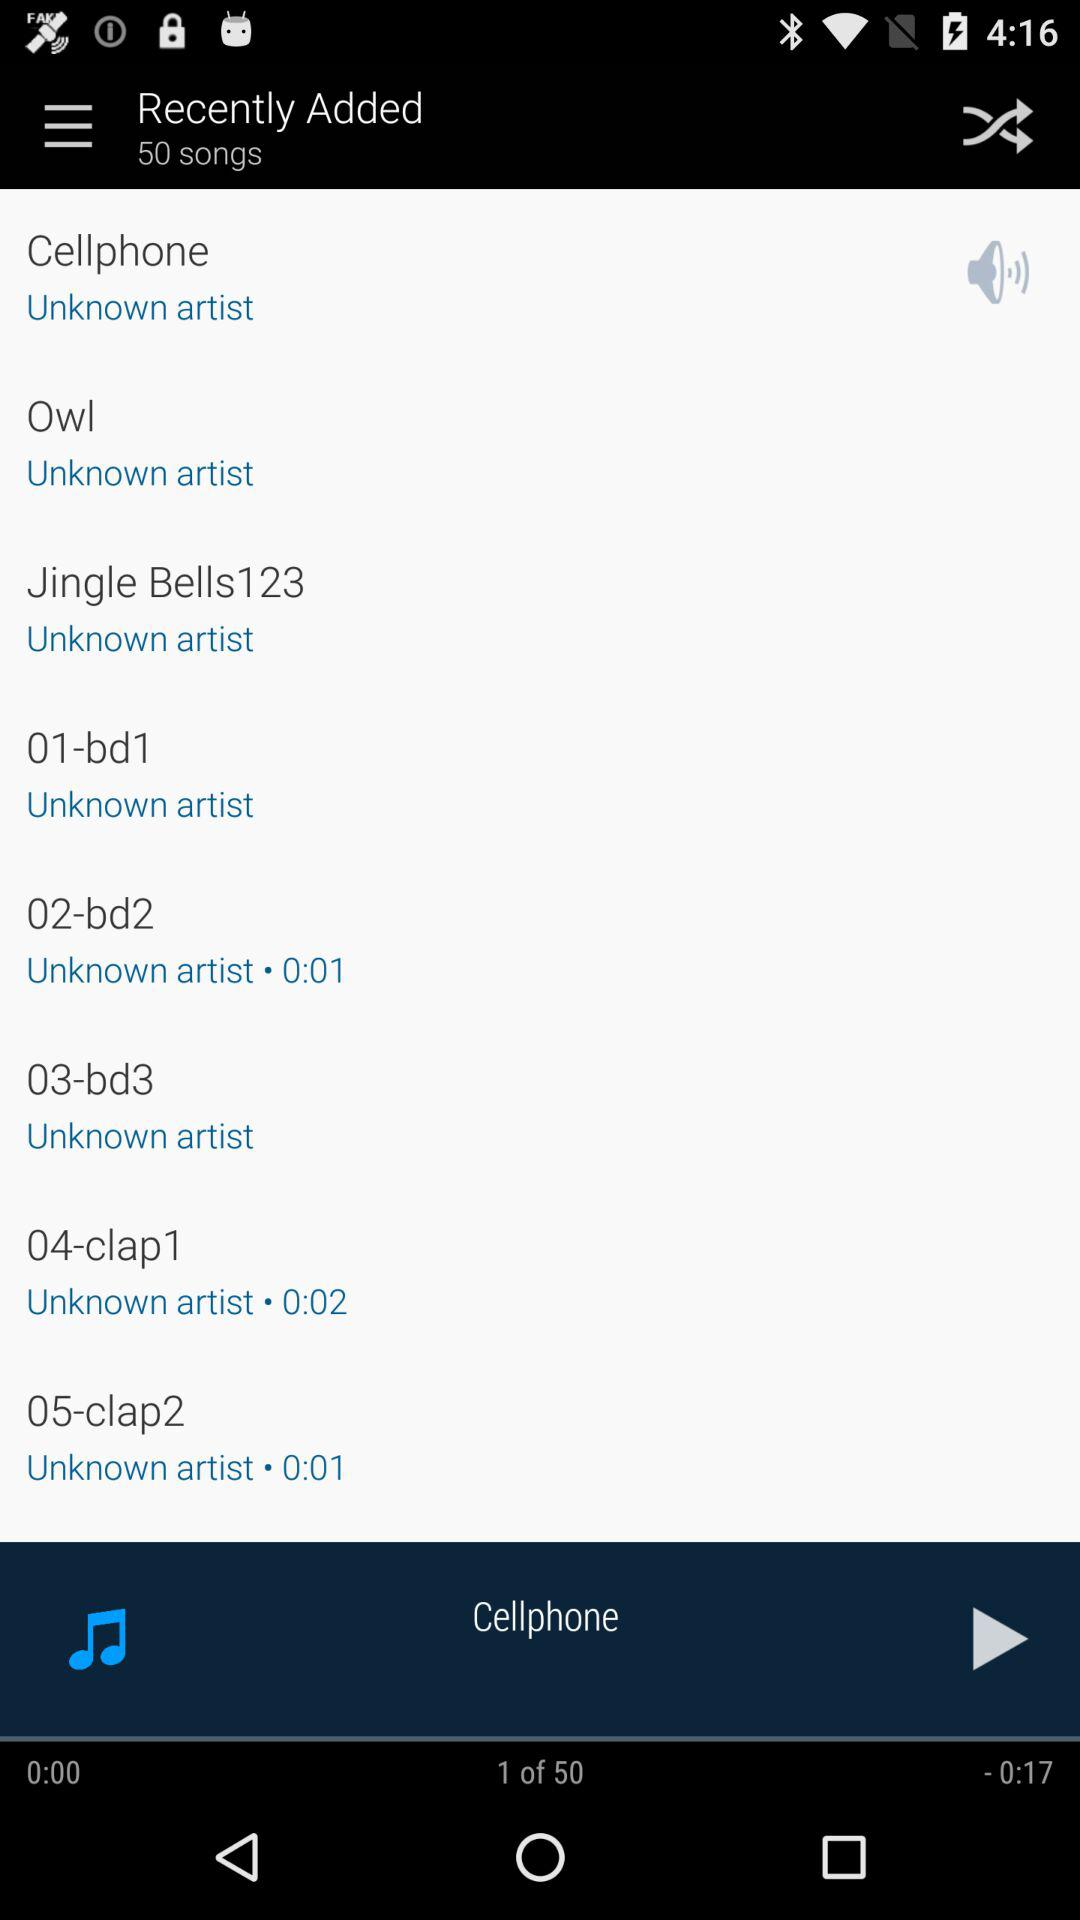How long is the "Owl" track?
When the provided information is insufficient, respond with <no answer>. <no answer> 